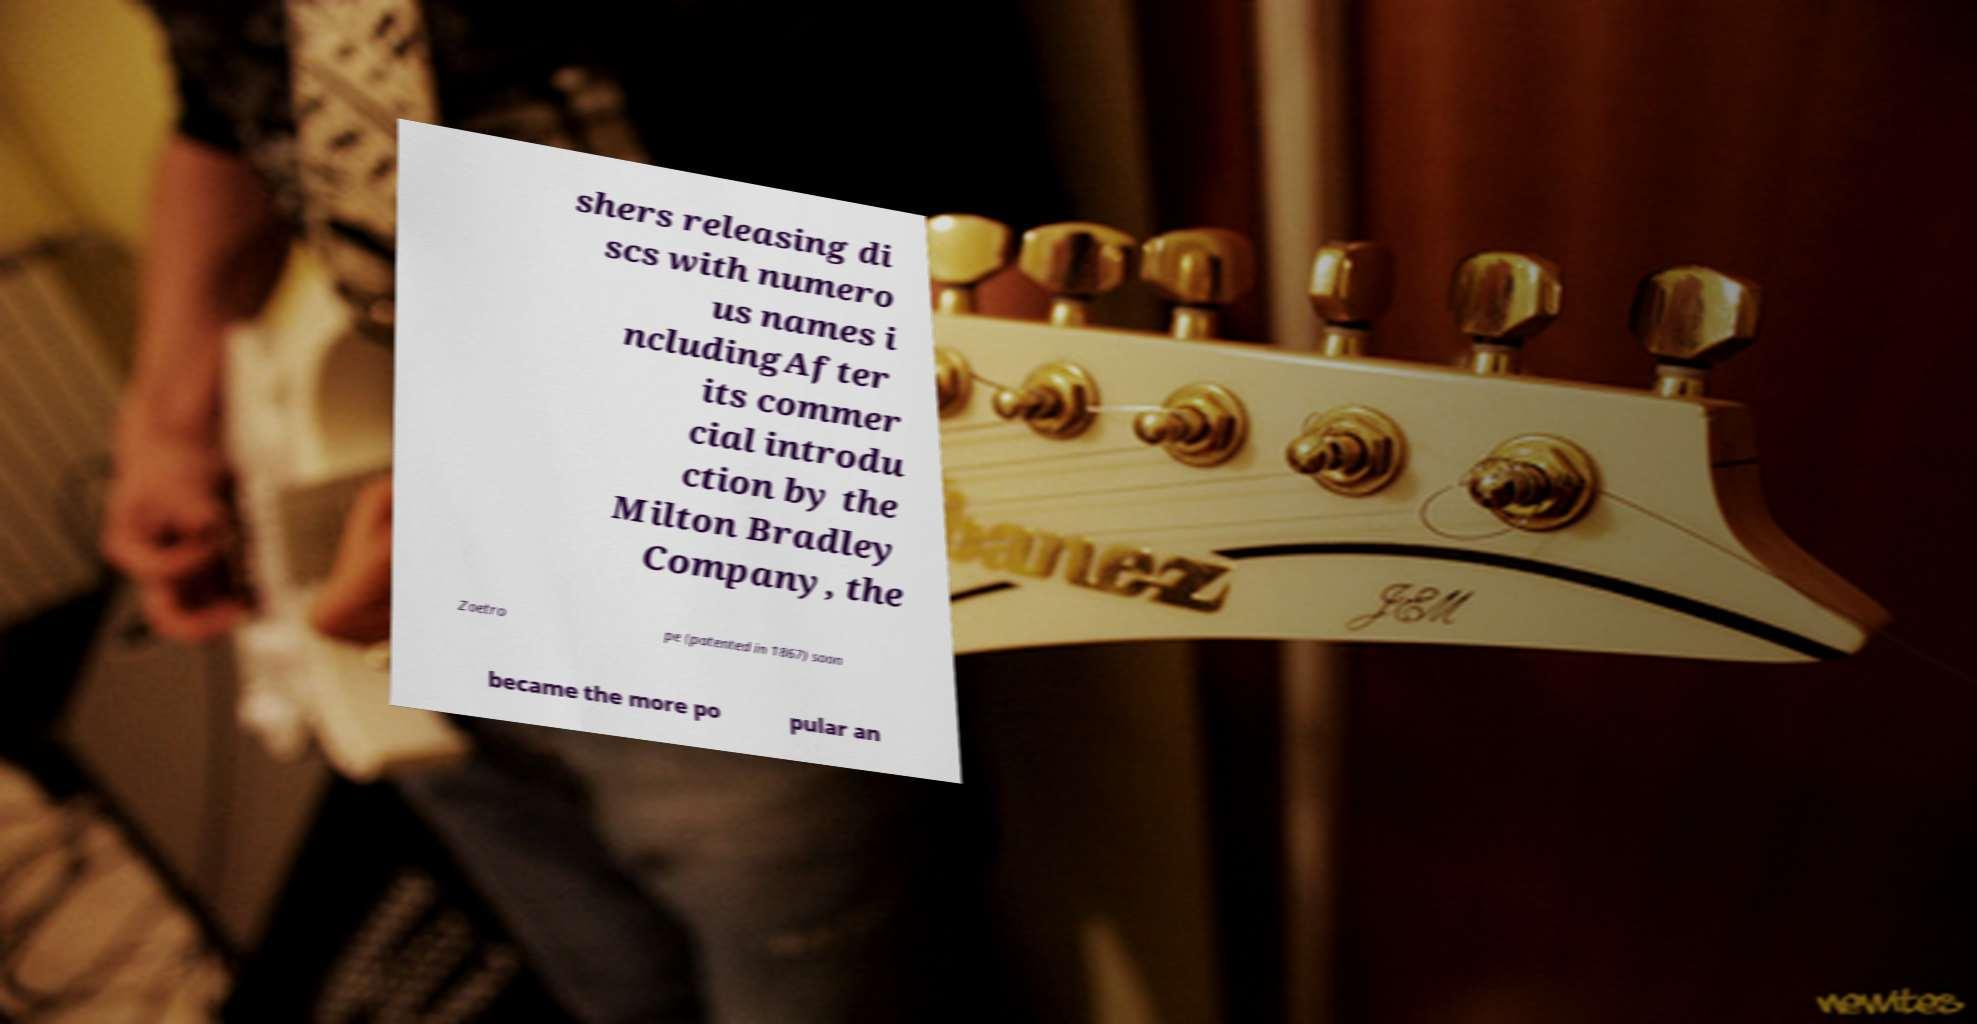Can you read and provide the text displayed in the image?This photo seems to have some interesting text. Can you extract and type it out for me? shers releasing di scs with numero us names i ncludingAfter its commer cial introdu ction by the Milton Bradley Company, the Zoetro pe (patented in 1867) soon became the more po pular an 